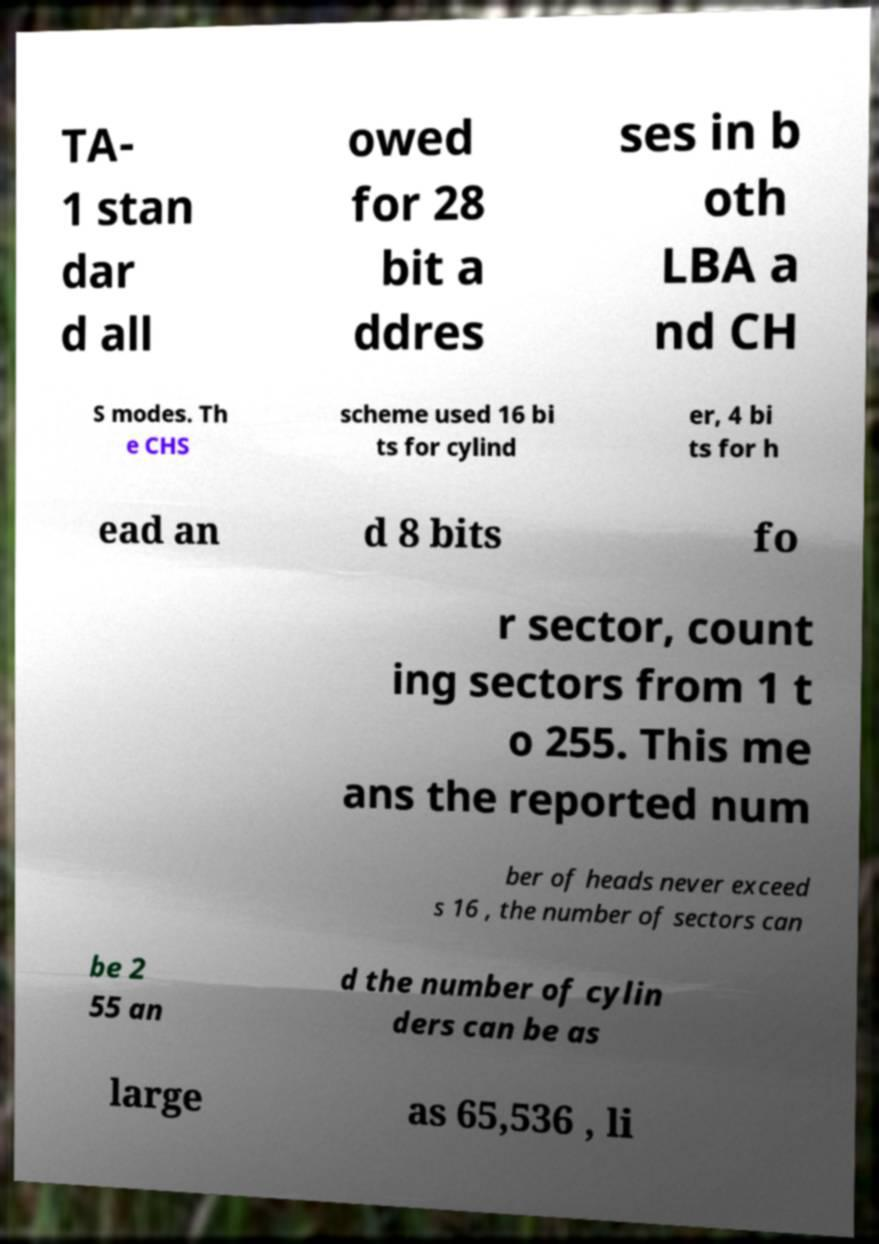I need the written content from this picture converted into text. Can you do that? TA- 1 stan dar d all owed for 28 bit a ddres ses in b oth LBA a nd CH S modes. Th e CHS scheme used 16 bi ts for cylind er, 4 bi ts for h ead an d 8 bits fo r sector, count ing sectors from 1 t o 255. This me ans the reported num ber of heads never exceed s 16 , the number of sectors can be 2 55 an d the number of cylin ders can be as large as 65,536 , li 